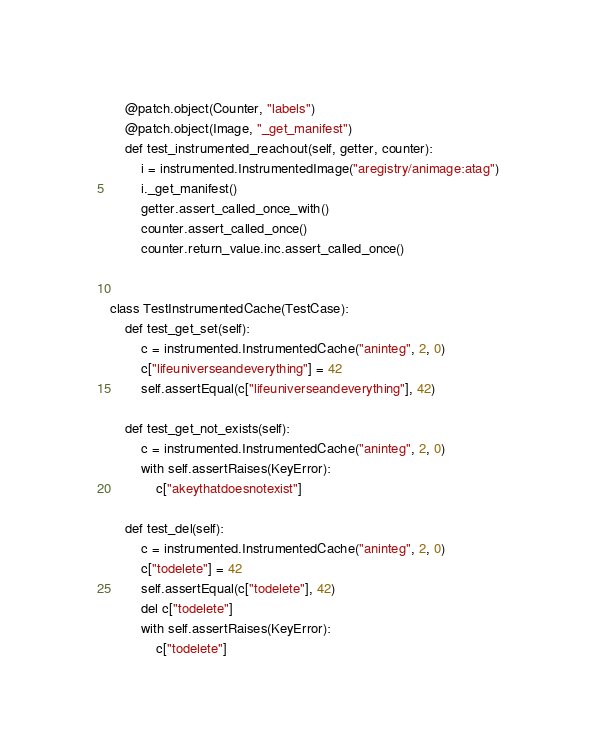<code> <loc_0><loc_0><loc_500><loc_500><_Python_>    @patch.object(Counter, "labels")
    @patch.object(Image, "_get_manifest")
    def test_instrumented_reachout(self, getter, counter):
        i = instrumented.InstrumentedImage("aregistry/animage:atag")
        i._get_manifest()
        getter.assert_called_once_with()
        counter.assert_called_once()
        counter.return_value.inc.assert_called_once()


class TestInstrumentedCache(TestCase):
    def test_get_set(self):
        c = instrumented.InstrumentedCache("aninteg", 2, 0)
        c["lifeuniverseandeverything"] = 42
        self.assertEqual(c["lifeuniverseandeverything"], 42)

    def test_get_not_exists(self):
        c = instrumented.InstrumentedCache("aninteg", 2, 0)
        with self.assertRaises(KeyError):
            c["akeythatdoesnotexist"]

    def test_del(self):
        c = instrumented.InstrumentedCache("aninteg", 2, 0)
        c["todelete"] = 42
        self.assertEqual(c["todelete"], 42)
        del c["todelete"]
        with self.assertRaises(KeyError):
            c["todelete"]
</code> 